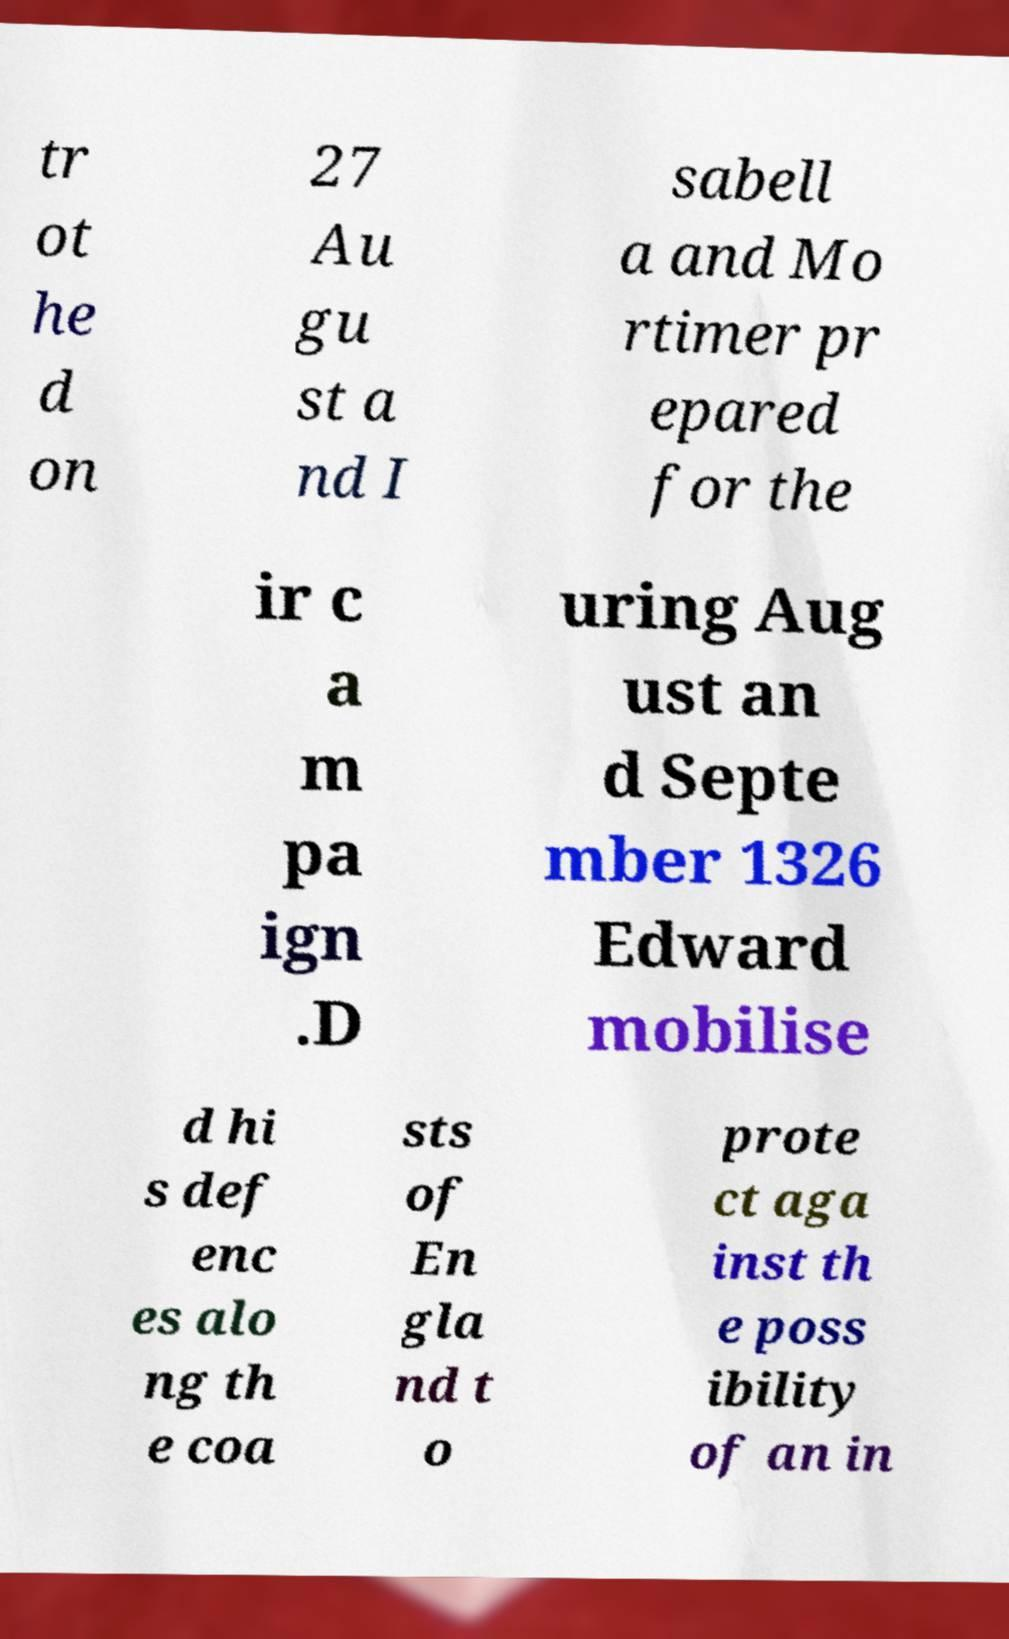Can you accurately transcribe the text from the provided image for me? tr ot he d on 27 Au gu st a nd I sabell a and Mo rtimer pr epared for the ir c a m pa ign .D uring Aug ust an d Septe mber 1326 Edward mobilise d hi s def enc es alo ng th e coa sts of En gla nd t o prote ct aga inst th e poss ibility of an in 